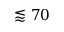Convert formula to latex. <formula><loc_0><loc_0><loc_500><loc_500>\lessapprox 7 0</formula> 